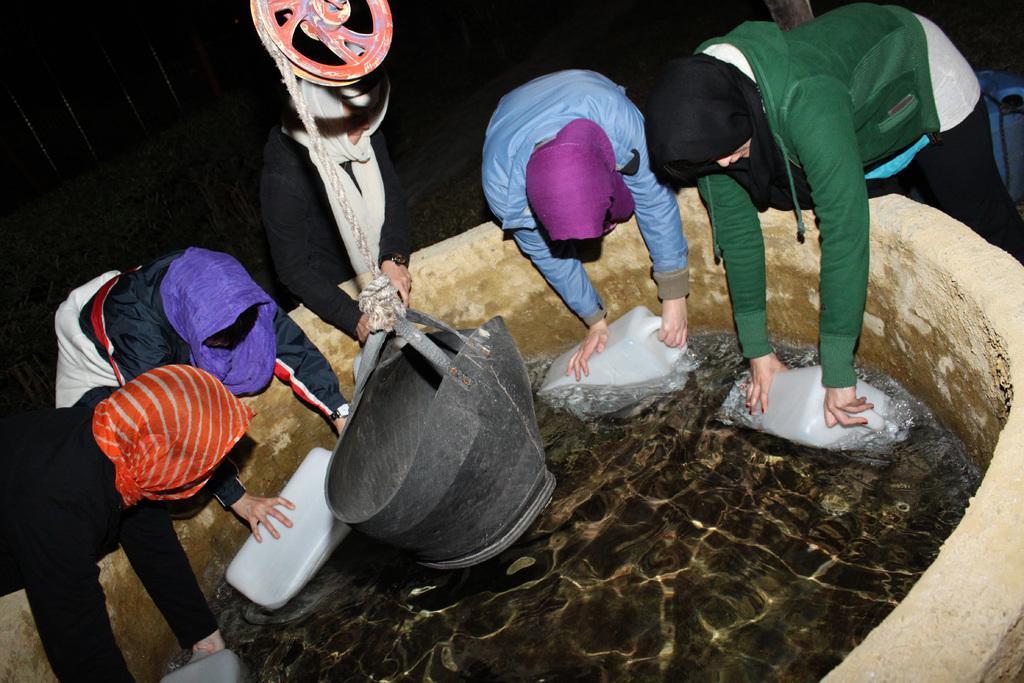Please provide a concise description of this image. In this picture, we see five people are filling water in the cans from the well. In the middle of the picture, we see a black bucket, rope and a pulley. At the bottom, we see the water in the well. In the background, it is black in color. 